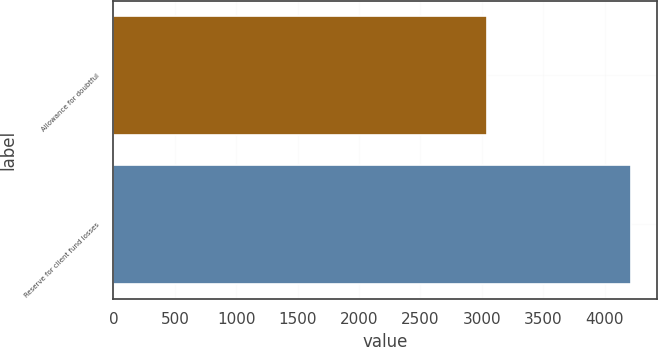Convert chart. <chart><loc_0><loc_0><loc_500><loc_500><bar_chart><fcel>Allowance for doubtful<fcel>Reserve for client fund losses<nl><fcel>3044<fcel>4214<nl></chart> 